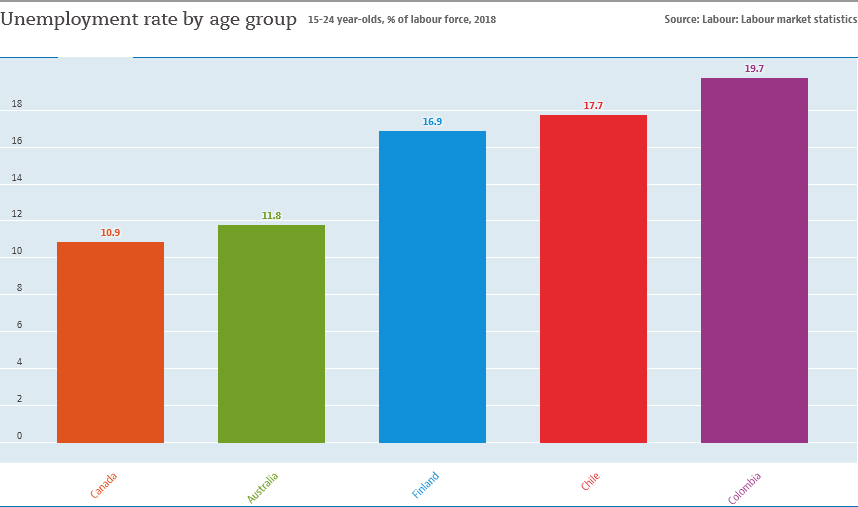List a handful of essential elements in this visual. Colombia is known for having the largest bar in the world. The difference between the largest and second-largest bar values is not greater than the value of the smallest bar. 